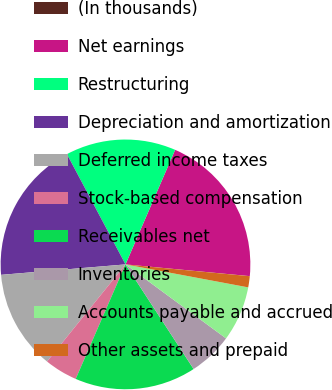Convert chart to OTSL. <chart><loc_0><loc_0><loc_500><loc_500><pie_chart><fcel>(In thousands)<fcel>Net earnings<fcel>Restructuring<fcel>Depreciation and amortization<fcel>Deferred income taxes<fcel>Stock-based compensation<fcel>Receivables net<fcel>Inventories<fcel>Accounts payable and accrued<fcel>Other assets and prepaid<nl><fcel>0.01%<fcel>19.99%<fcel>14.28%<fcel>18.56%<fcel>12.85%<fcel>4.29%<fcel>15.71%<fcel>5.72%<fcel>7.15%<fcel>1.44%<nl></chart> 